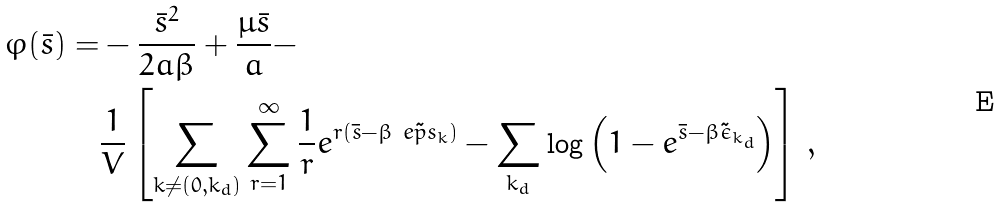<formula> <loc_0><loc_0><loc_500><loc_500>\varphi ( \bar { s } ) = & - \frac { \bar { s } ^ { 2 } } { 2 a \beta } + \frac { \mu \bar { s } } { a } - \\ & \frac { 1 } { V } \left [ \sum _ { k \neq ( { 0 } , k _ { d } ) } \sum _ { r = 1 } ^ { \infty } \frac { 1 } { r } e ^ { r ( \bar { s } - \beta \tilde { \ e p s _ { k } } ) } - \sum _ { k _ { d } } \log \left ( 1 - e ^ { \bar { s } - \beta \tilde { \epsilon } _ { k _ { d } } } \right ) \right ] \, ,</formula> 